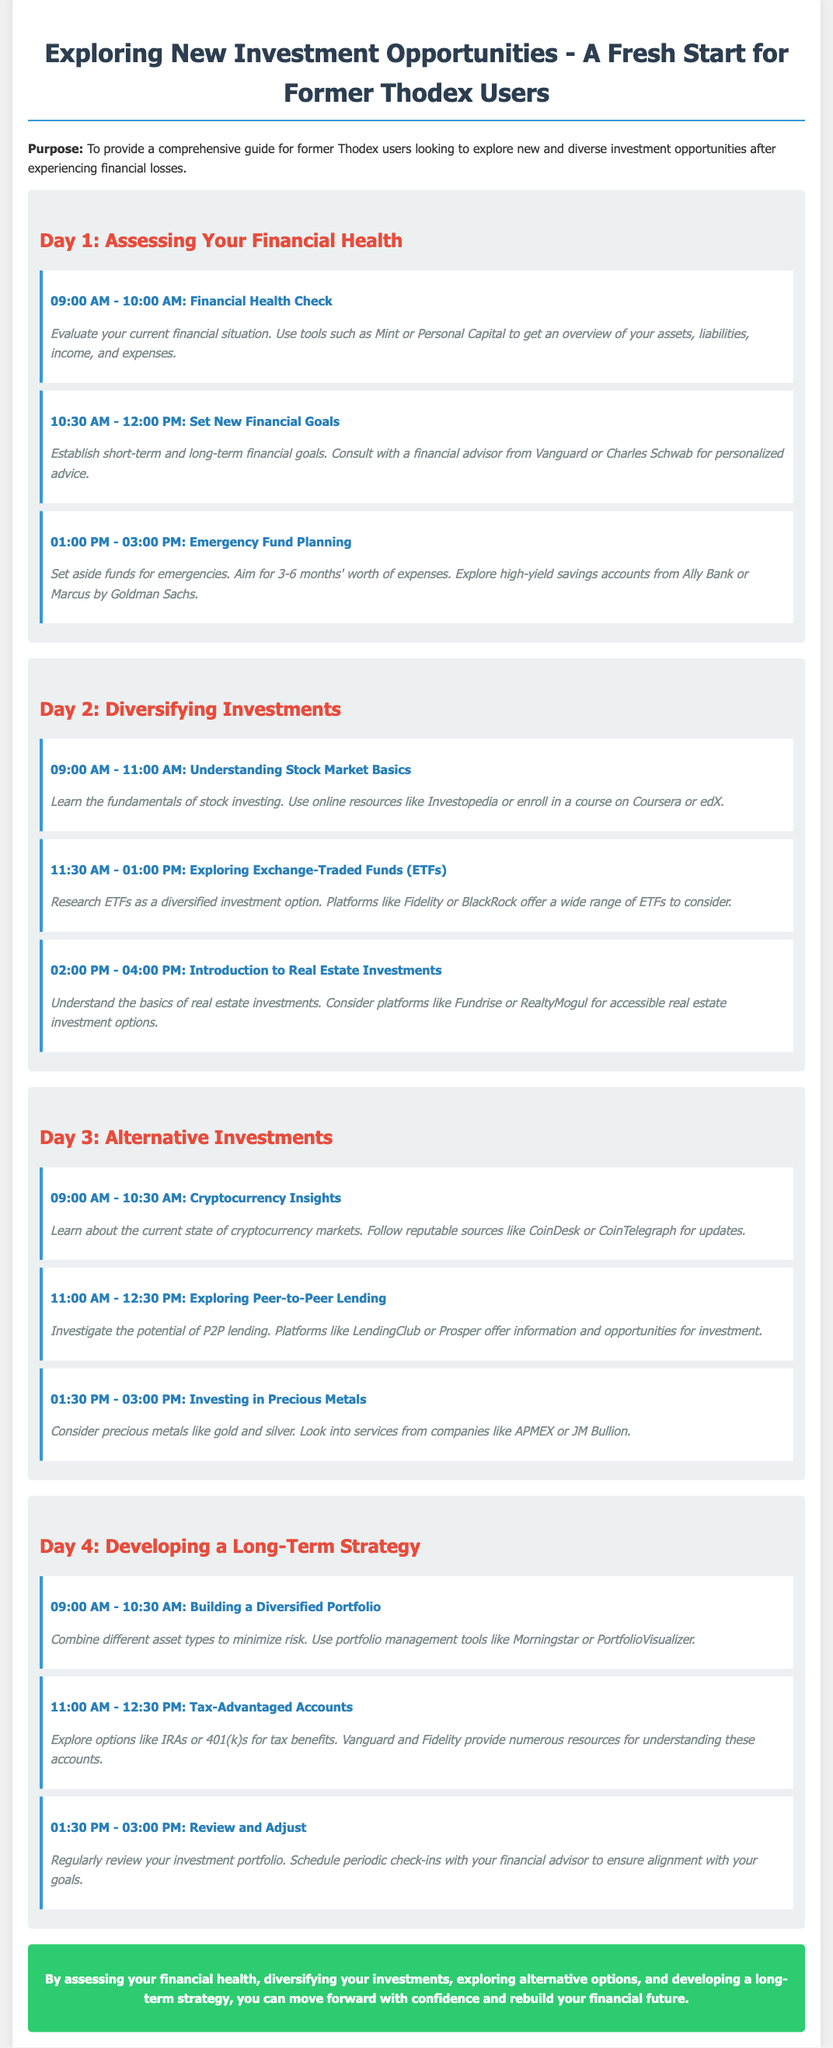What is the title of the document? The title is specified at the beginning of the document.
Answer: Exploring New Investment Opportunities - A Fresh Start for Former Thodex Users What time does the Financial Health Check start? The time is listed in the schedule for Day 1.
Answer: 09:00 AM Which platform offers a variety of ETFs? The document mentions specific platforms under the activity on ETFs.
Answer: Fidelity How many months' worth of expenses should an emergency fund aim for? This is stated in the Emergency Fund Planning section of Day 1.
Answer: 3-6 months What is the focus of Day 3? The document outlines the theme for each day, particularly Day 3.
Answer: Alternative Investments What are two companies mentioned for investing in precious metals? The activity on investing in precious metals lists specific companies.
Answer: APMEX or JM Bullion What tool can be used for portfolio management? This information is provided in Day 4 under Building a Diversified Portfolio.
Answer: Morningstar Which accounts are mentioned for tax advantages? The activity discussing tax benefits specifies types of accounts.
Answer: IRAs or 401(k)s What is the final message of the document? The conclusion summarizes the key takeaway from the itinerary.
Answer: Move forward with confidence and rebuild your financial future 